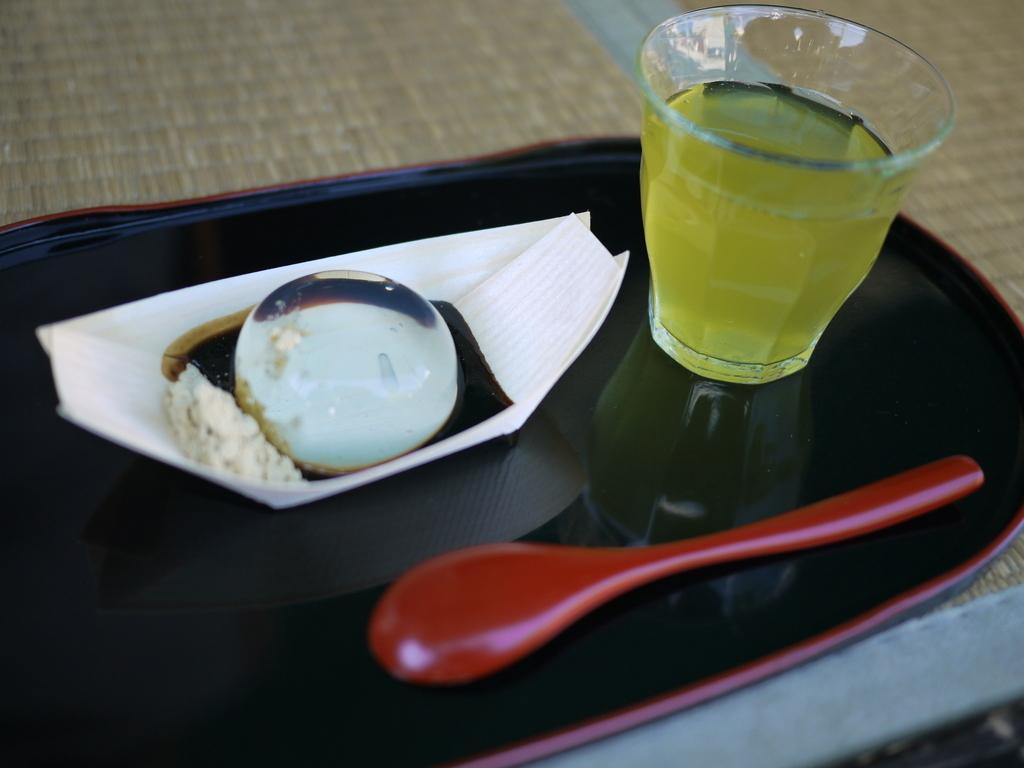Could you give a brief overview of what you see in this image? In this picture we can see a tray with spoon, tissue paper, ball and aside to this a glass with drink in it and this is placed on a floor or a table. 